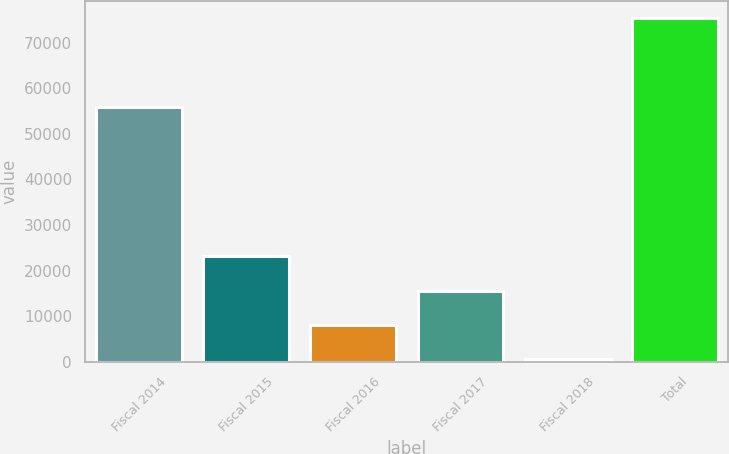<chart> <loc_0><loc_0><loc_500><loc_500><bar_chart><fcel>Fiscal 2014<fcel>Fiscal 2015<fcel>Fiscal 2016<fcel>Fiscal 2017<fcel>Fiscal 2018<fcel>Total<nl><fcel>55935<fcel>23135.7<fcel>8211.9<fcel>15673.8<fcel>750<fcel>75369<nl></chart> 